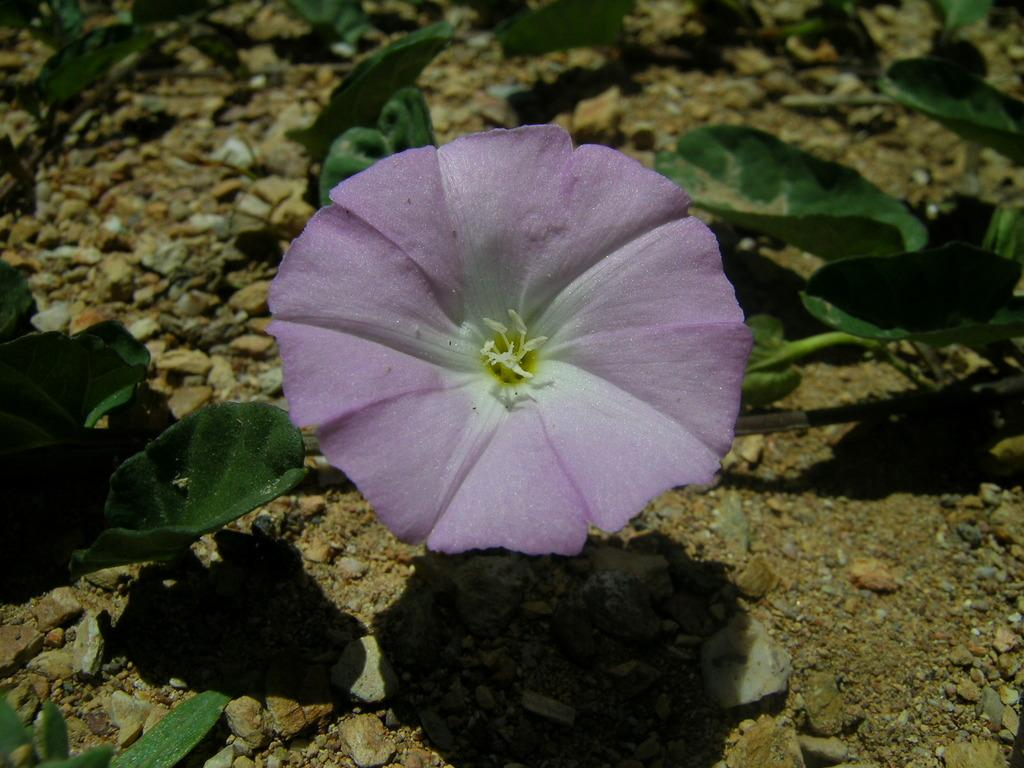What color is the flower in the image? The flower in the image is violet. What is the flower a part of? The flower is part of a plant. What color are the leaves of the plant? The leaves of the plant are green. Where are the flower and leaves located? The flower and leaves are on the ground. What else can be found on the ground in the image? There are stones on the ground. What type of pen is being used to draw the flower in the image? There is no pen or drawing activity present in the image; it features a real violet flower and green leaves on the ground. 